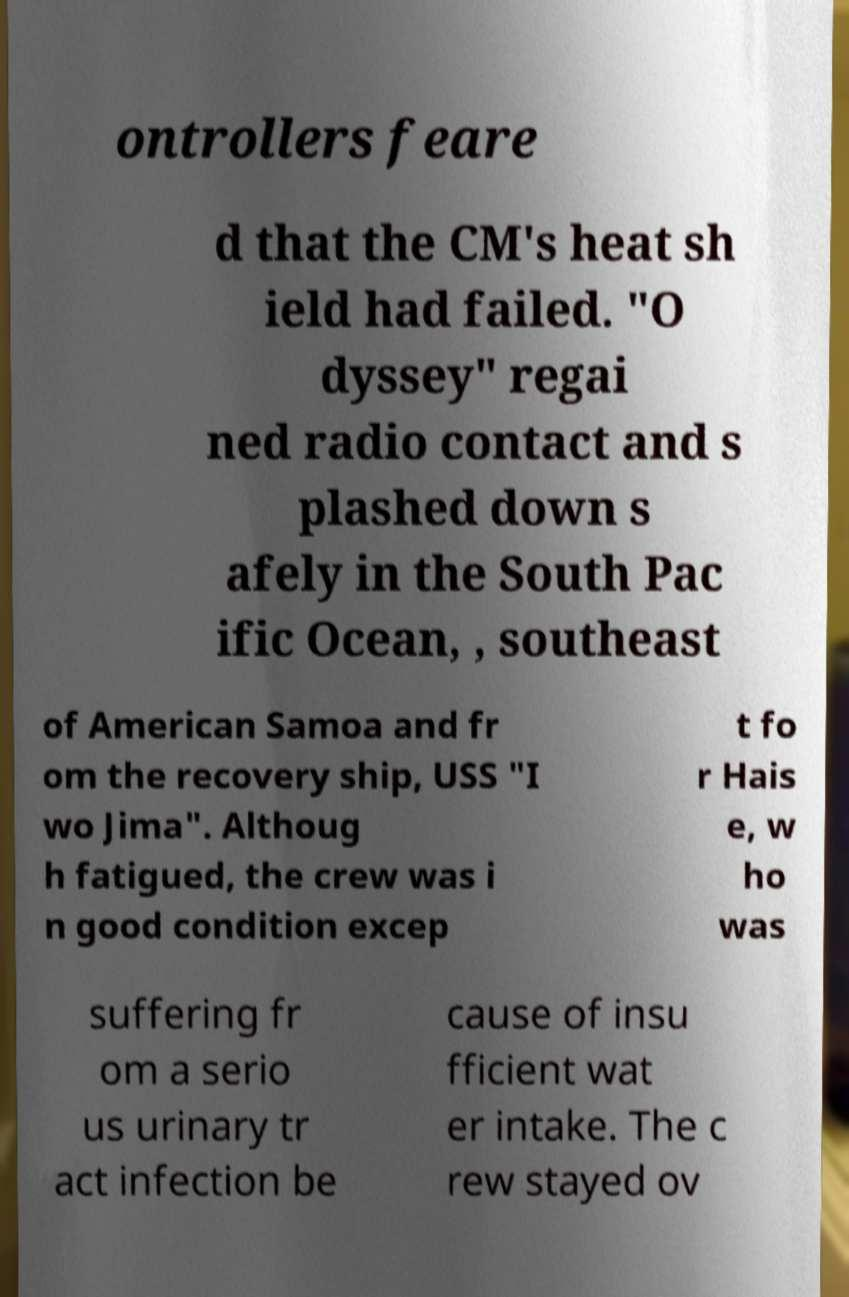Could you extract and type out the text from this image? ontrollers feare d that the CM's heat sh ield had failed. "O dyssey" regai ned radio contact and s plashed down s afely in the South Pac ific Ocean, , southeast of American Samoa and fr om the recovery ship, USS "I wo Jima". Althoug h fatigued, the crew was i n good condition excep t fo r Hais e, w ho was suffering fr om a serio us urinary tr act infection be cause of insu fficient wat er intake. The c rew stayed ov 